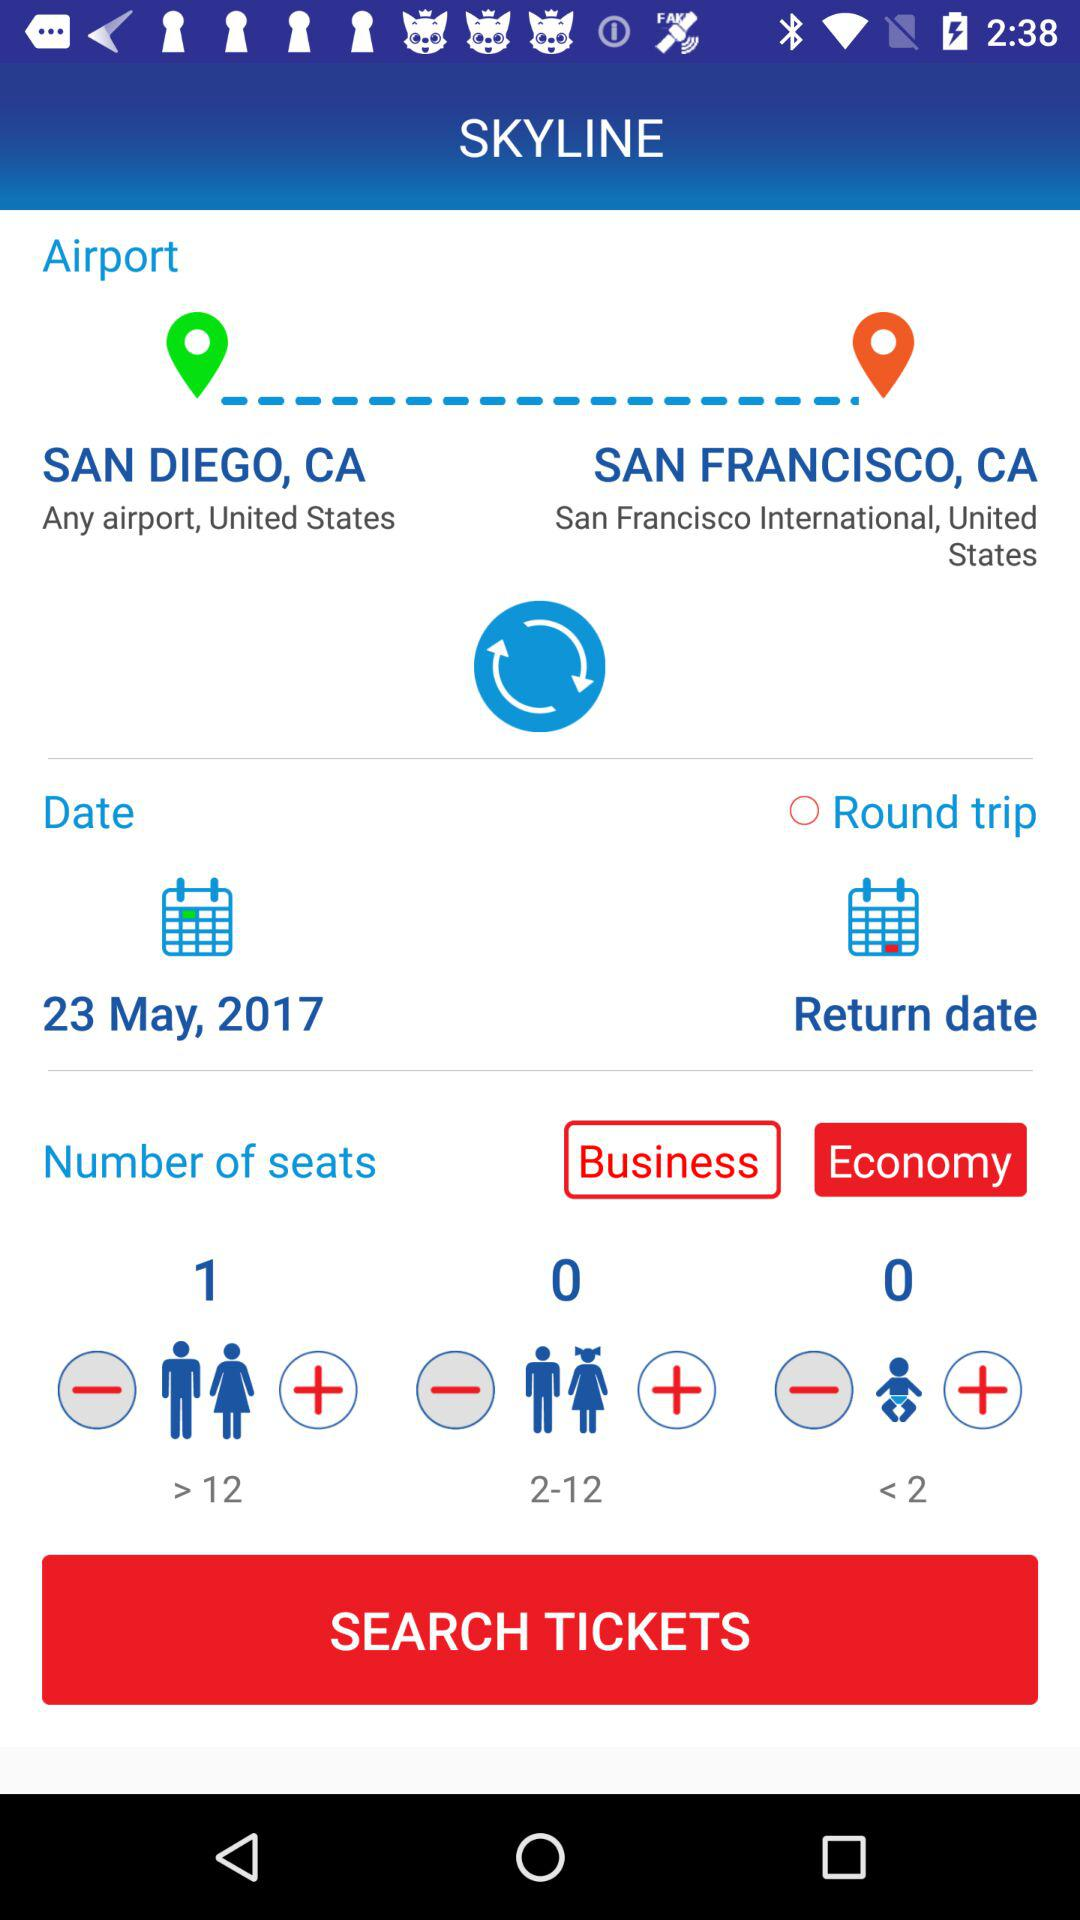Is "Round trip" selected or not? It is not selected. 